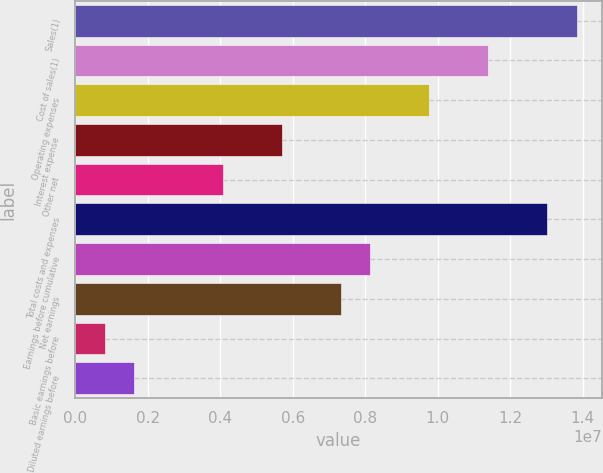Convert chart to OTSL. <chart><loc_0><loc_0><loc_500><loc_500><bar_chart><fcel>Sales(1)<fcel>Cost of sales(1)<fcel>Operating expenses<fcel>Interest expense<fcel>Other net<fcel>Total costs and expenses<fcel>Earnings before cumulative<fcel>Net earnings<fcel>Basic earnings before<fcel>Diluted earnings before<nl><fcel>1.38343e+07<fcel>1.13929e+07<fcel>9.76538e+06<fcel>5.69647e+06<fcel>4.06891e+06<fcel>1.30205e+07<fcel>8.13782e+06<fcel>7.32403e+06<fcel>813782<fcel>1.62756e+06<nl></chart> 